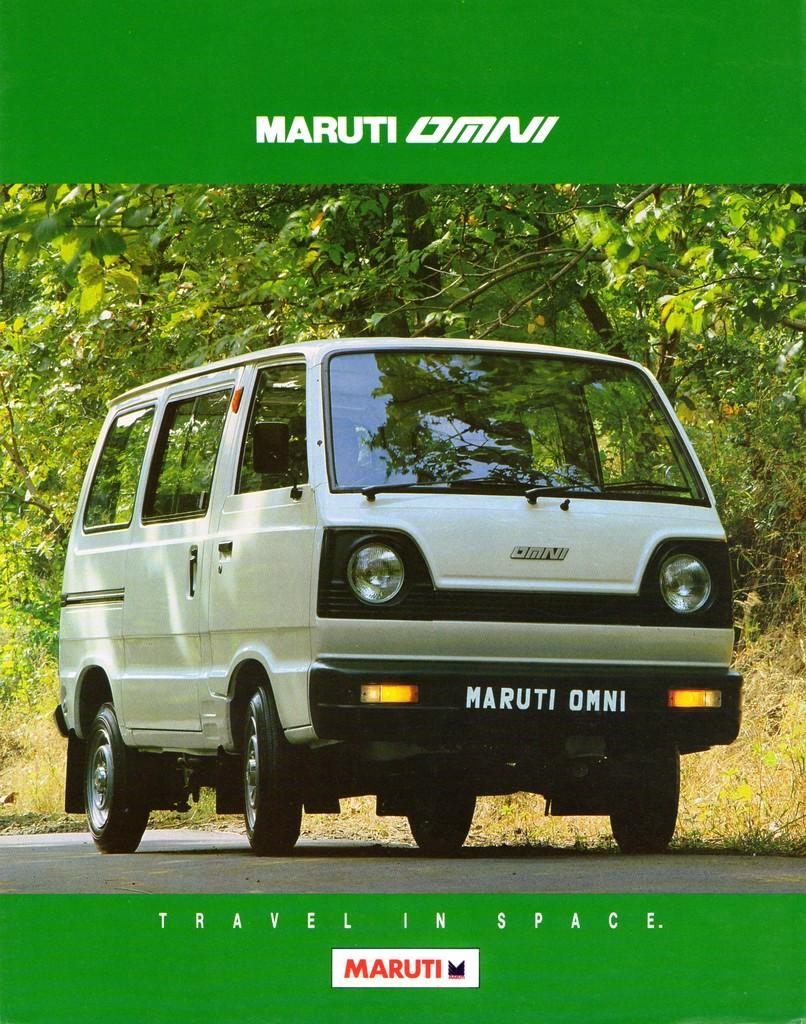Please provide a concise description of this image. In this image there is a vehicle on the road, behind the vehicle there are trees and grass. At the top and bottom of the image there is some text. 